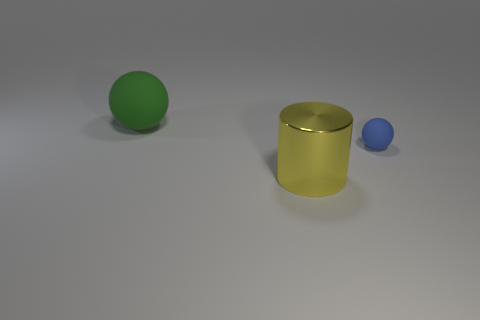Add 1 yellow cylinders. How many objects exist? 4 Subtract all spheres. How many objects are left? 1 Subtract 0 green cylinders. How many objects are left? 3 Subtract all tiny blue rubber spheres. Subtract all large yellow metal cylinders. How many objects are left? 1 Add 2 large yellow cylinders. How many large yellow cylinders are left? 3 Add 2 large yellow shiny objects. How many large yellow shiny objects exist? 3 